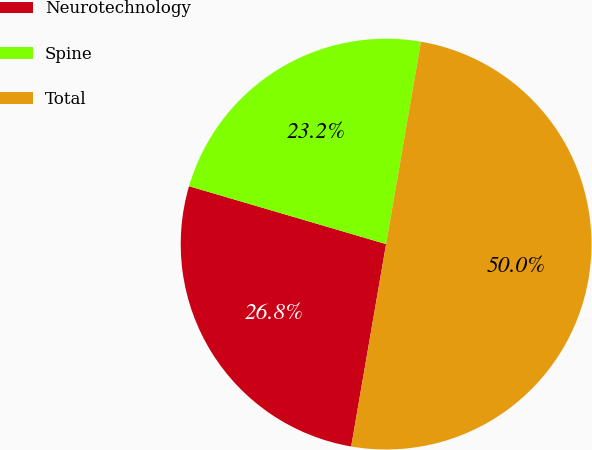<chart> <loc_0><loc_0><loc_500><loc_500><pie_chart><fcel>Neurotechnology<fcel>Spine<fcel>Total<nl><fcel>26.83%<fcel>23.17%<fcel>50.0%<nl></chart> 